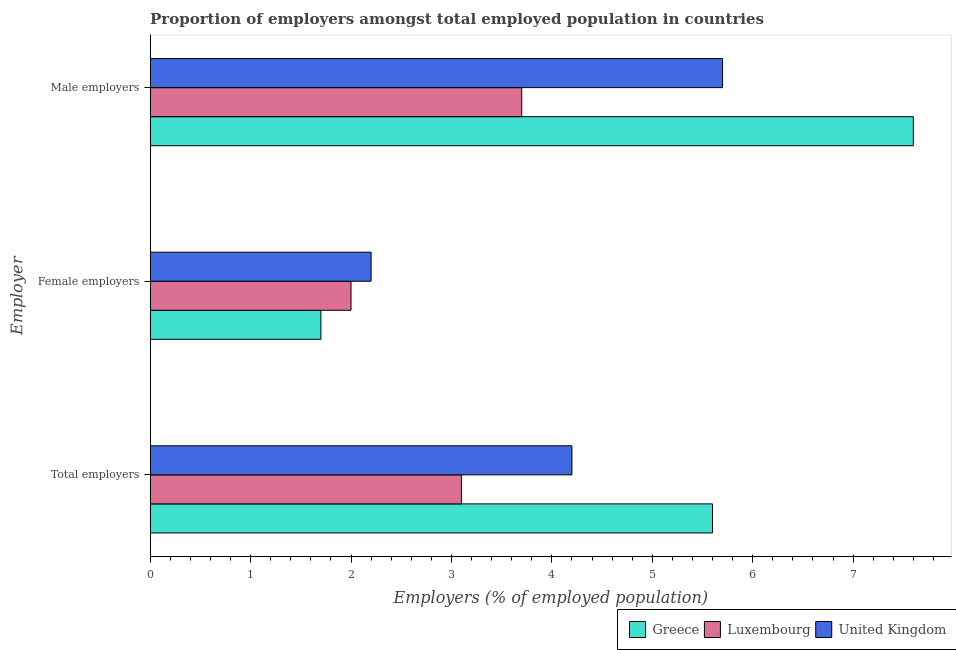How many different coloured bars are there?
Offer a very short reply. 3. How many groups of bars are there?
Ensure brevity in your answer.  3. Are the number of bars per tick equal to the number of legend labels?
Your answer should be very brief. Yes. What is the label of the 2nd group of bars from the top?
Your answer should be very brief. Female employers. What is the percentage of male employers in Luxembourg?
Make the answer very short. 3.7. Across all countries, what is the maximum percentage of male employers?
Keep it short and to the point. 7.6. Across all countries, what is the minimum percentage of male employers?
Keep it short and to the point. 3.7. In which country was the percentage of male employers minimum?
Provide a short and direct response. Luxembourg. What is the total percentage of male employers in the graph?
Make the answer very short. 17. What is the difference between the percentage of total employers in Greece and that in Luxembourg?
Make the answer very short. 2.5. What is the difference between the percentage of total employers in United Kingdom and the percentage of female employers in Luxembourg?
Your response must be concise. 2.2. What is the average percentage of female employers per country?
Ensure brevity in your answer.  1.97. What is the difference between the percentage of male employers and percentage of female employers in United Kingdom?
Your answer should be very brief. 3.5. What is the ratio of the percentage of total employers in United Kingdom to that in Luxembourg?
Offer a very short reply. 1.35. Is the difference between the percentage of total employers in Greece and United Kingdom greater than the difference between the percentage of female employers in Greece and United Kingdom?
Provide a succinct answer. Yes. What is the difference between the highest and the second highest percentage of male employers?
Keep it short and to the point. 1.9. What is the difference between the highest and the lowest percentage of female employers?
Your response must be concise. 0.5. In how many countries, is the percentage of male employers greater than the average percentage of male employers taken over all countries?
Your answer should be compact. 2. Is the sum of the percentage of female employers in Luxembourg and United Kingdom greater than the maximum percentage of total employers across all countries?
Provide a short and direct response. No. What does the 1st bar from the top in Total employers represents?
Your answer should be compact. United Kingdom. What does the 2nd bar from the bottom in Female employers represents?
Your answer should be compact. Luxembourg. Is it the case that in every country, the sum of the percentage of total employers and percentage of female employers is greater than the percentage of male employers?
Give a very brief answer. No. How many countries are there in the graph?
Keep it short and to the point. 3. What is the difference between two consecutive major ticks on the X-axis?
Keep it short and to the point. 1. Does the graph contain any zero values?
Your answer should be very brief. No. Does the graph contain grids?
Your answer should be compact. No. How many legend labels are there?
Your response must be concise. 3. How are the legend labels stacked?
Give a very brief answer. Horizontal. What is the title of the graph?
Your answer should be very brief. Proportion of employers amongst total employed population in countries. Does "Kuwait" appear as one of the legend labels in the graph?
Your answer should be very brief. No. What is the label or title of the X-axis?
Provide a short and direct response. Employers (% of employed population). What is the label or title of the Y-axis?
Offer a very short reply. Employer. What is the Employers (% of employed population) in Greece in Total employers?
Your response must be concise. 5.6. What is the Employers (% of employed population) in Luxembourg in Total employers?
Give a very brief answer. 3.1. What is the Employers (% of employed population) in United Kingdom in Total employers?
Provide a succinct answer. 4.2. What is the Employers (% of employed population) of Greece in Female employers?
Your response must be concise. 1.7. What is the Employers (% of employed population) of Luxembourg in Female employers?
Your answer should be very brief. 2. What is the Employers (% of employed population) in United Kingdom in Female employers?
Keep it short and to the point. 2.2. What is the Employers (% of employed population) of Greece in Male employers?
Provide a succinct answer. 7.6. What is the Employers (% of employed population) of Luxembourg in Male employers?
Your answer should be very brief. 3.7. What is the Employers (% of employed population) of United Kingdom in Male employers?
Your response must be concise. 5.7. Across all Employer, what is the maximum Employers (% of employed population) in Greece?
Provide a succinct answer. 7.6. Across all Employer, what is the maximum Employers (% of employed population) in Luxembourg?
Provide a short and direct response. 3.7. Across all Employer, what is the maximum Employers (% of employed population) in United Kingdom?
Make the answer very short. 5.7. Across all Employer, what is the minimum Employers (% of employed population) in Greece?
Make the answer very short. 1.7. Across all Employer, what is the minimum Employers (% of employed population) in Luxembourg?
Make the answer very short. 2. Across all Employer, what is the minimum Employers (% of employed population) in United Kingdom?
Provide a short and direct response. 2.2. What is the total Employers (% of employed population) of Luxembourg in the graph?
Your answer should be compact. 8.8. What is the total Employers (% of employed population) in United Kingdom in the graph?
Make the answer very short. 12.1. What is the difference between the Employers (% of employed population) in Greece in Total employers and that in Female employers?
Offer a terse response. 3.9. What is the difference between the Employers (% of employed population) of United Kingdom in Total employers and that in Female employers?
Give a very brief answer. 2. What is the difference between the Employers (% of employed population) of United Kingdom in Total employers and that in Male employers?
Your answer should be compact. -1.5. What is the difference between the Employers (% of employed population) of Greece in Female employers and that in Male employers?
Your answer should be very brief. -5.9. What is the difference between the Employers (% of employed population) in Luxembourg in Female employers and that in Male employers?
Offer a very short reply. -1.7. What is the difference between the Employers (% of employed population) in United Kingdom in Female employers and that in Male employers?
Provide a succinct answer. -3.5. What is the difference between the Employers (% of employed population) in Greece in Total employers and the Employers (% of employed population) in United Kingdom in Female employers?
Offer a very short reply. 3.4. What is the difference between the Employers (% of employed population) of Luxembourg in Total employers and the Employers (% of employed population) of United Kingdom in Male employers?
Provide a succinct answer. -2.6. What is the difference between the Employers (% of employed population) of Greece in Female employers and the Employers (% of employed population) of Luxembourg in Male employers?
Offer a terse response. -2. What is the average Employers (% of employed population) in Greece per Employer?
Offer a terse response. 4.97. What is the average Employers (% of employed population) in Luxembourg per Employer?
Provide a succinct answer. 2.93. What is the average Employers (% of employed population) of United Kingdom per Employer?
Provide a succinct answer. 4.03. What is the difference between the Employers (% of employed population) of Greece and Employers (% of employed population) of United Kingdom in Total employers?
Provide a succinct answer. 1.4. What is the difference between the Employers (% of employed population) of Greece and Employers (% of employed population) of United Kingdom in Female employers?
Your answer should be very brief. -0.5. What is the difference between the Employers (% of employed population) in Luxembourg and Employers (% of employed population) in United Kingdom in Female employers?
Your answer should be compact. -0.2. What is the difference between the Employers (% of employed population) of Greece and Employers (% of employed population) of United Kingdom in Male employers?
Provide a short and direct response. 1.9. What is the difference between the Employers (% of employed population) of Luxembourg and Employers (% of employed population) of United Kingdom in Male employers?
Give a very brief answer. -2. What is the ratio of the Employers (% of employed population) in Greece in Total employers to that in Female employers?
Keep it short and to the point. 3.29. What is the ratio of the Employers (% of employed population) in Luxembourg in Total employers to that in Female employers?
Offer a very short reply. 1.55. What is the ratio of the Employers (% of employed population) of United Kingdom in Total employers to that in Female employers?
Make the answer very short. 1.91. What is the ratio of the Employers (% of employed population) in Greece in Total employers to that in Male employers?
Your response must be concise. 0.74. What is the ratio of the Employers (% of employed population) of Luxembourg in Total employers to that in Male employers?
Provide a short and direct response. 0.84. What is the ratio of the Employers (% of employed population) of United Kingdom in Total employers to that in Male employers?
Ensure brevity in your answer.  0.74. What is the ratio of the Employers (% of employed population) in Greece in Female employers to that in Male employers?
Give a very brief answer. 0.22. What is the ratio of the Employers (% of employed population) in Luxembourg in Female employers to that in Male employers?
Keep it short and to the point. 0.54. What is the ratio of the Employers (% of employed population) of United Kingdom in Female employers to that in Male employers?
Give a very brief answer. 0.39. What is the difference between the highest and the second highest Employers (% of employed population) in Luxembourg?
Keep it short and to the point. 0.6. What is the difference between the highest and the lowest Employers (% of employed population) of Greece?
Keep it short and to the point. 5.9. What is the difference between the highest and the lowest Employers (% of employed population) in Luxembourg?
Your answer should be compact. 1.7. 